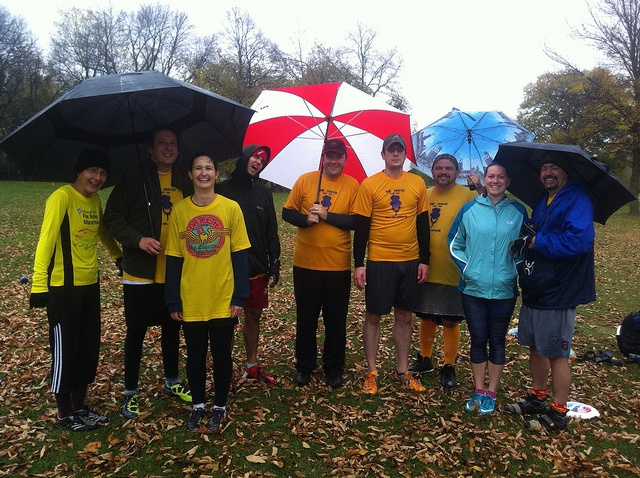Describe the objects in this image and their specific colors. I can see umbrella in ivory, black, and gray tones, people in ivory, black, navy, maroon, and darkblue tones, people in ivory, black, and olive tones, people in ivory, black, olive, and yellow tones, and people in ivory, black, olive, and maroon tones in this image. 